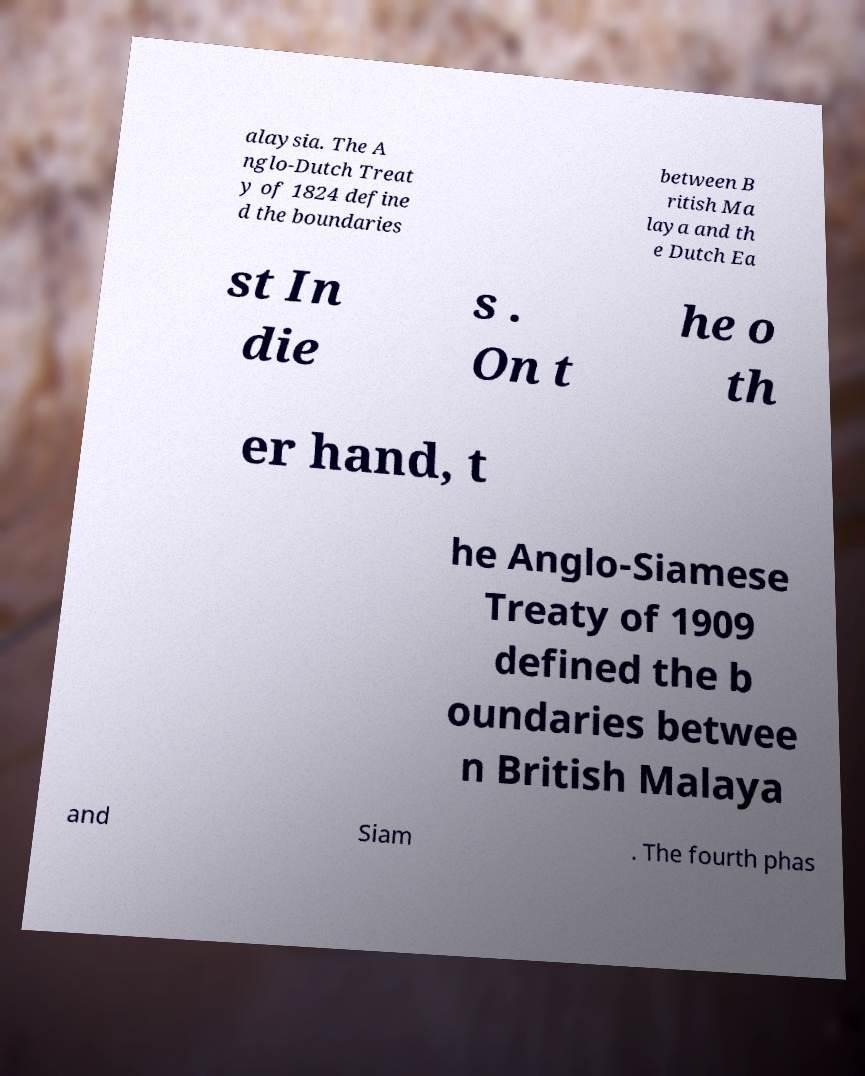Please identify and transcribe the text found in this image. alaysia. The A nglo-Dutch Treat y of 1824 define d the boundaries between B ritish Ma laya and th e Dutch Ea st In die s . On t he o th er hand, t he Anglo-Siamese Treaty of 1909 defined the b oundaries betwee n British Malaya and Siam . The fourth phas 